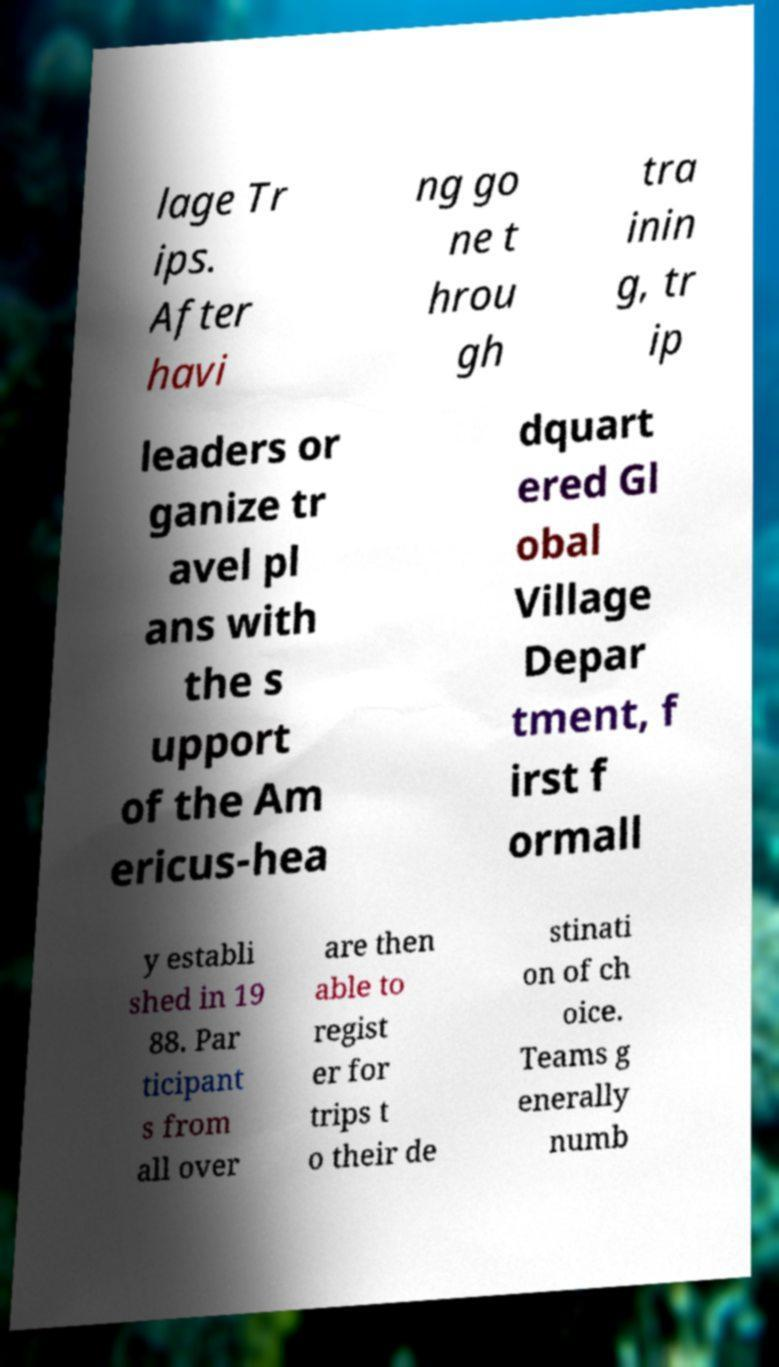For documentation purposes, I need the text within this image transcribed. Could you provide that? lage Tr ips. After havi ng go ne t hrou gh tra inin g, tr ip leaders or ganize tr avel pl ans with the s upport of the Am ericus-hea dquart ered Gl obal Village Depar tment, f irst f ormall y establi shed in 19 88. Par ticipant s from all over are then able to regist er for trips t o their de stinati on of ch oice. Teams g enerally numb 